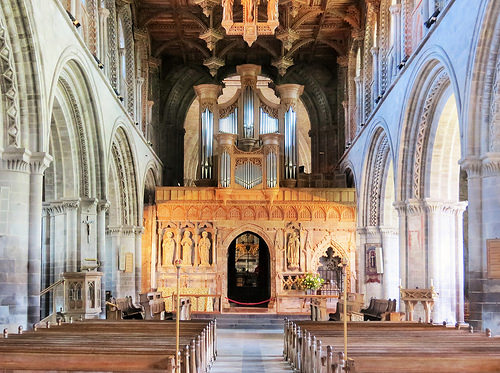<image>
Is there a arch next to the wall? Yes. The arch is positioned adjacent to the wall, located nearby in the same general area. 